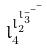Convert formula to latex. <formula><loc_0><loc_0><loc_500><loc_500>l _ { 4 } ^ { l _ { 2 } ^ { l _ { 3 } ^ { - ^ { - ^ { - } } } } }</formula> 